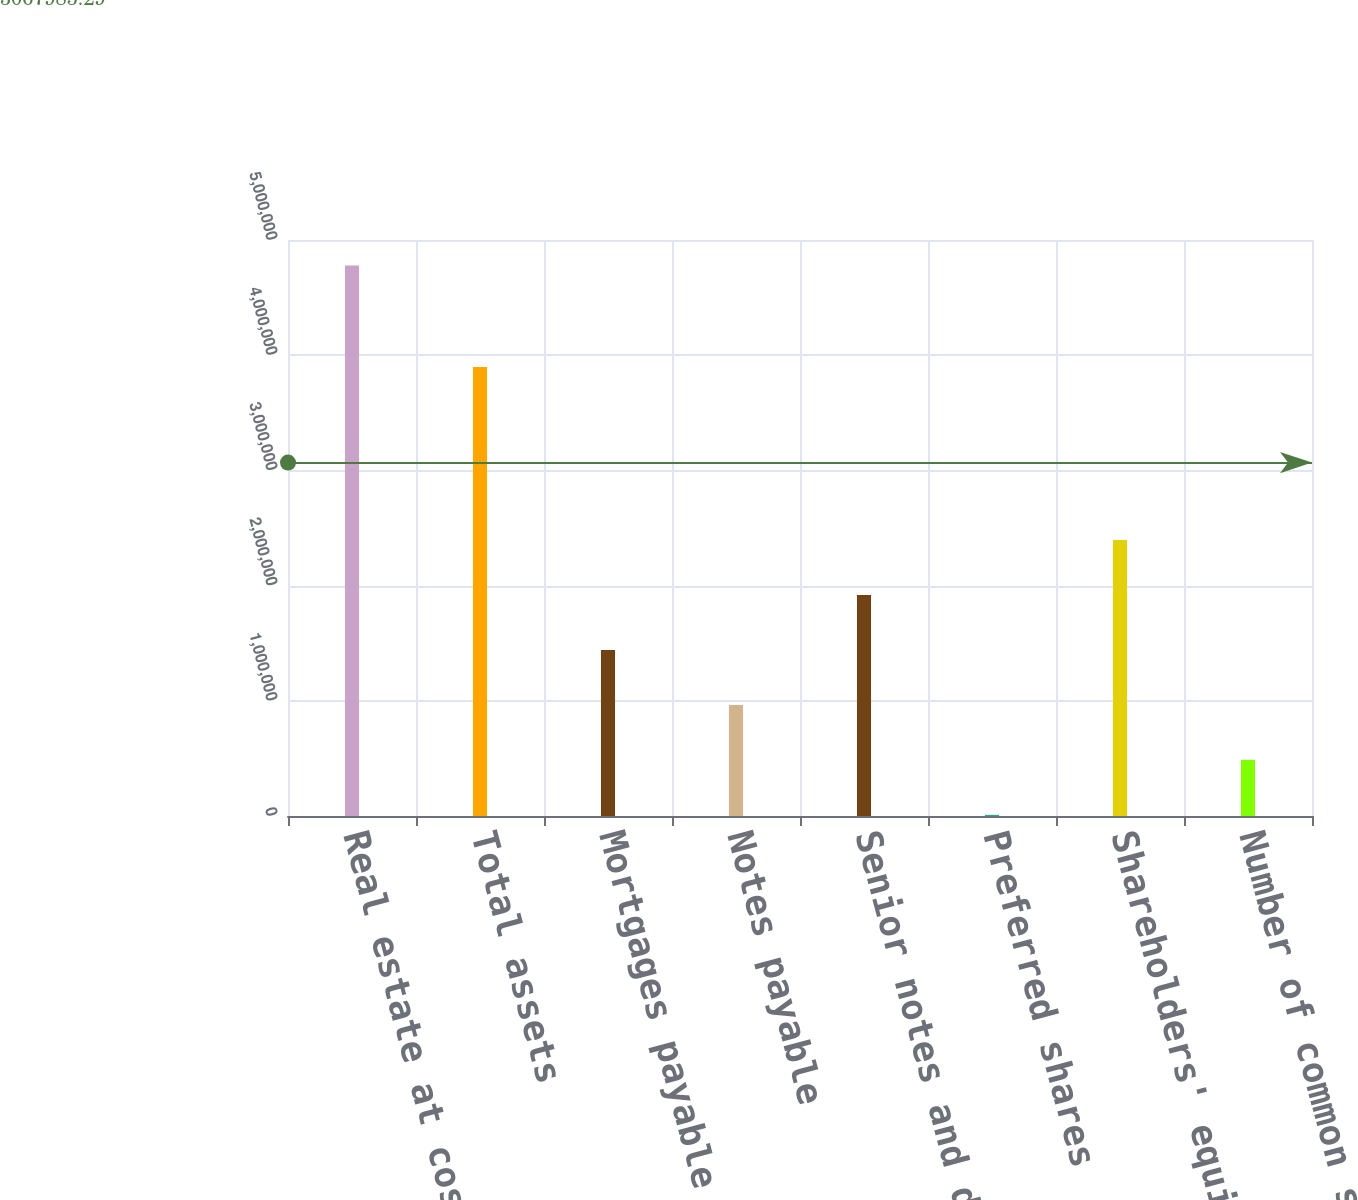Convert chart. <chart><loc_0><loc_0><loc_500><loc_500><bar_chart><fcel>Real estate at cost<fcel>Total assets<fcel>Mortgages payable and capital<fcel>Notes payable<fcel>Senior notes and debentures<fcel>Preferred shares<fcel>Shareholders' equity<fcel>Number of common shares<nl><fcel>4.77967e+06<fcel>3.89856e+06<fcel>1.4409e+06<fcel>963932<fcel>1.91787e+06<fcel>9997<fcel>2.39484e+06<fcel>486965<nl></chart> 